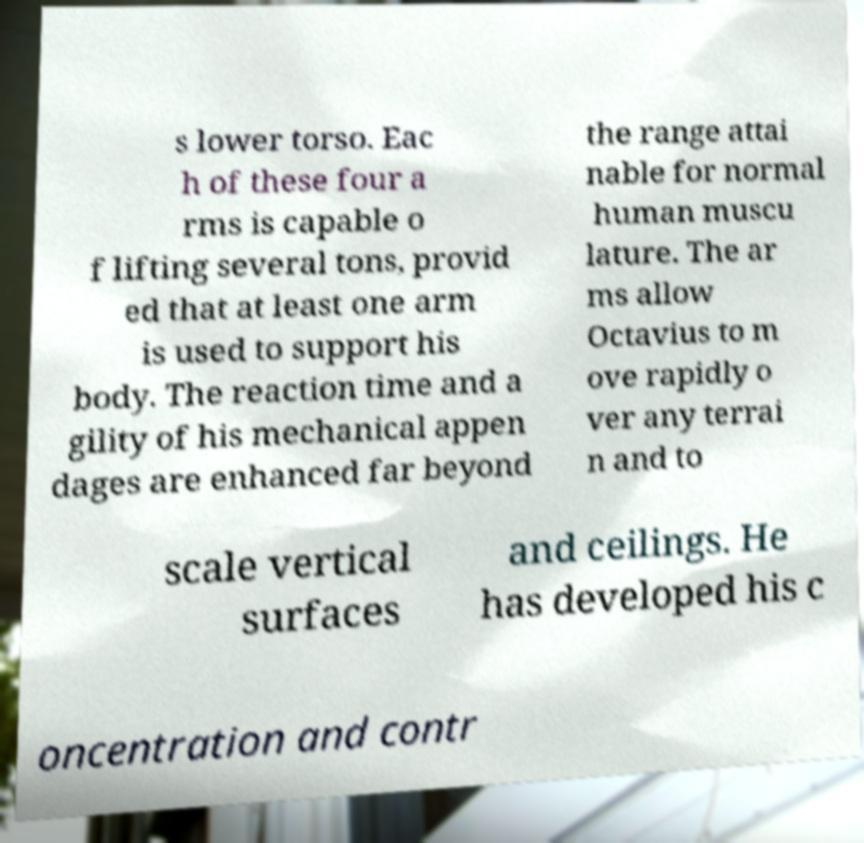For documentation purposes, I need the text within this image transcribed. Could you provide that? s lower torso. Eac h of these four a rms is capable o f lifting several tons, provid ed that at least one arm is used to support his body. The reaction time and a gility of his mechanical appen dages are enhanced far beyond the range attai nable for normal human muscu lature. The ar ms allow Octavius to m ove rapidly o ver any terrai n and to scale vertical surfaces and ceilings. He has developed his c oncentration and contr 